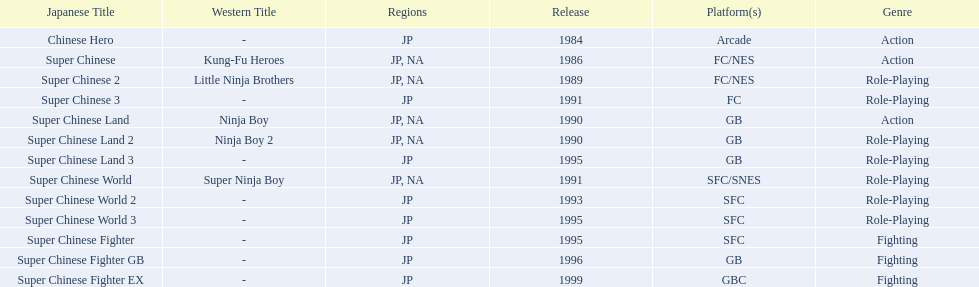Which platforms had the most titles released? GB. 